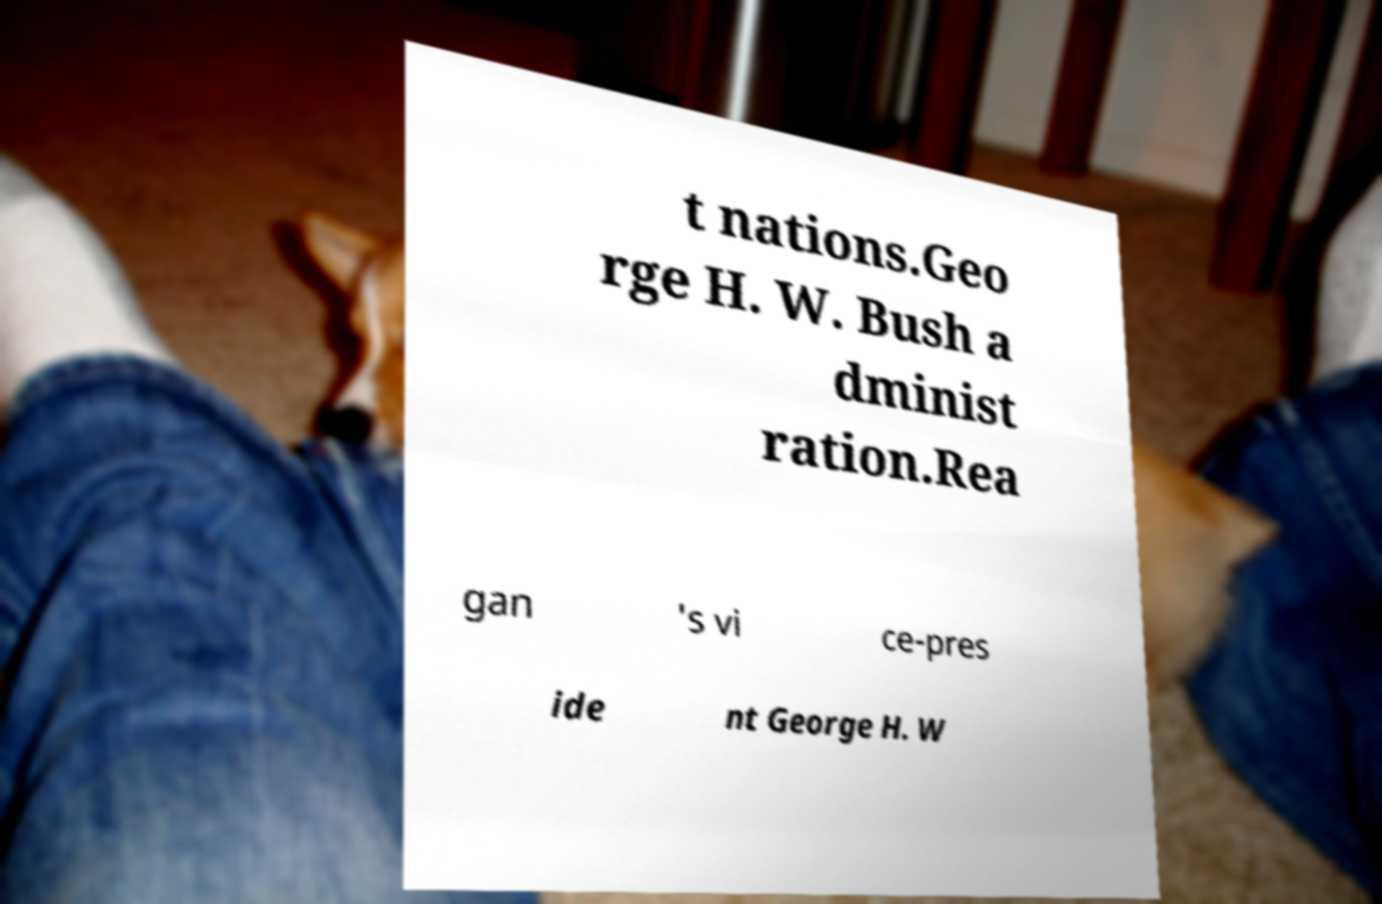Please read and relay the text visible in this image. What does it say? t nations.Geo rge H. W. Bush a dminist ration.Rea gan 's vi ce-pres ide nt George H. W 